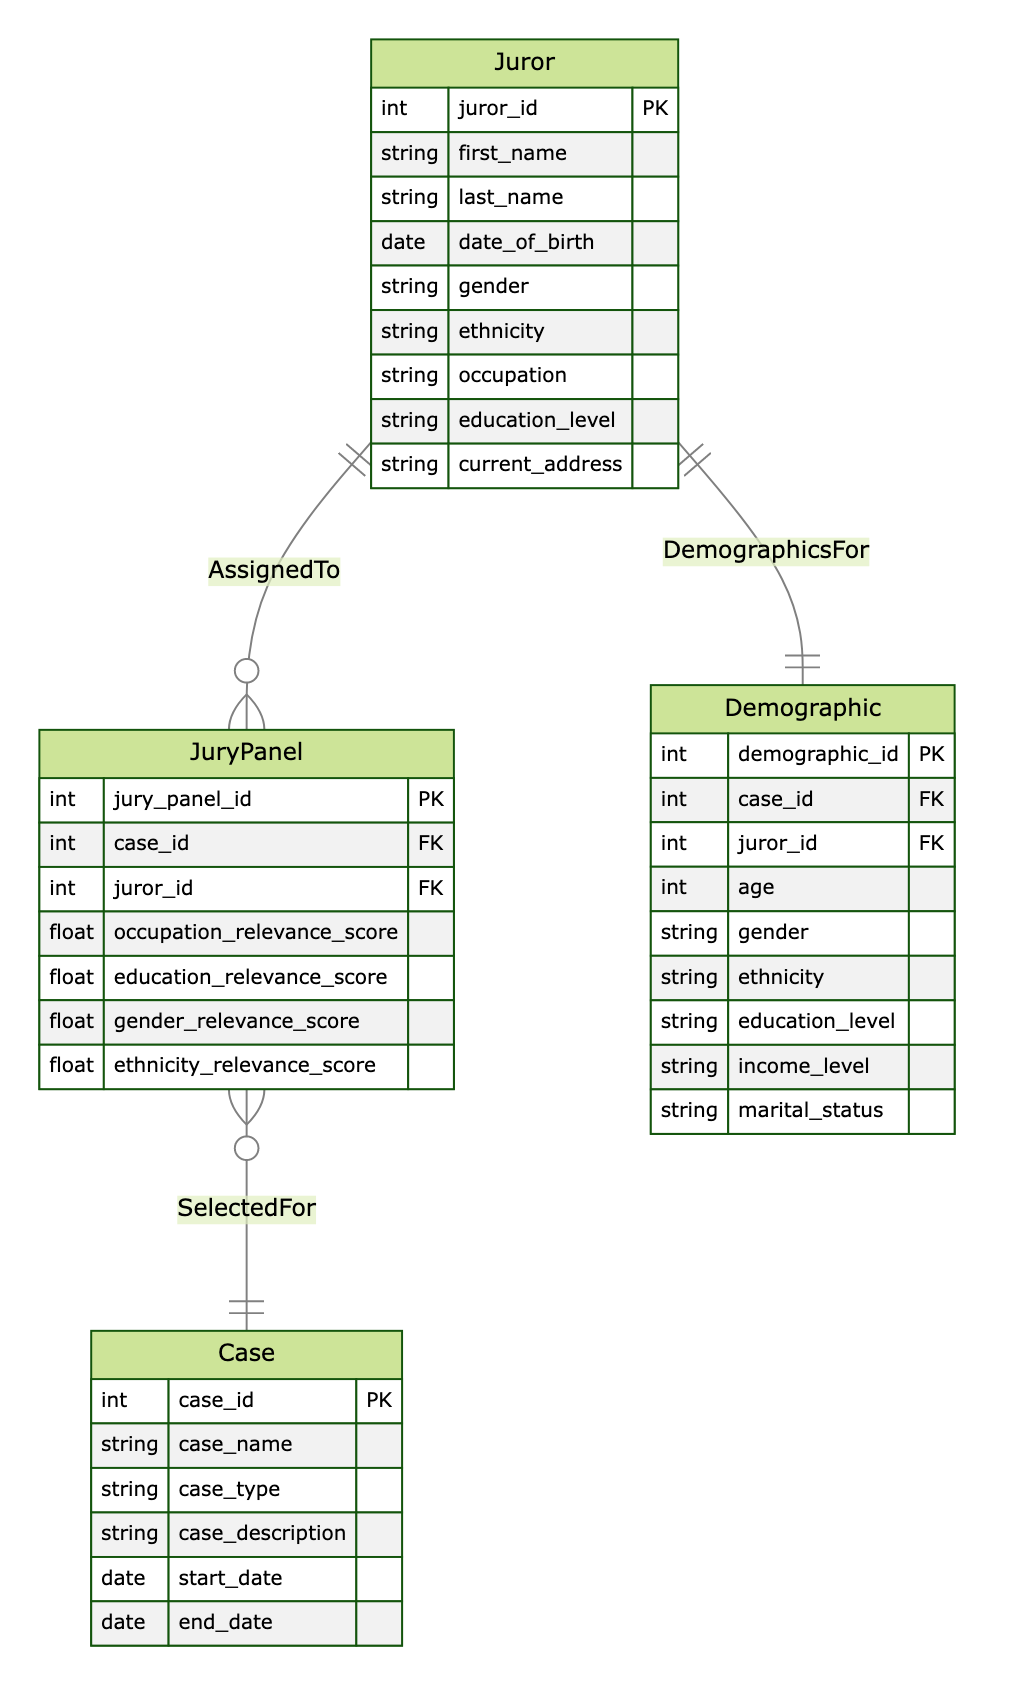What are the attributes of the Juror entity? The Juror entity has the following attributes: juror_id, first_name, last_name, date_of_birth, gender, ethnicity, occupation, education_level, and current_address.
Answer: juror_id, first_name, last_name, date_of_birth, gender, ethnicity, occupation, education_level, current_address How many entities are in the diagram? The diagram contains four entities: Juror, Case, JuryPanel, and Demographic.
Answer: 4 What is the relationship between JuryPanel and Case? The relationship between JuryPanel and Case is defined as "SelectedFor", indicating that a jury panel is selected for a specific case.
Answer: SelectedFor What attributes are associated with the JuryPanel entity? The JuryPanel entity has the attributes: jury_panel_id, case_id, juror_id, occupation_relevance_score, education_relevance_score, gender_relevance_score, and ethnicity_relevance_score.
Answer: jury_panel_id, case_id, juror_id, occupation_relevance_score, education_relevance_score, gender_relevance_score, ethnicity_relevance_score What does the AssignedTo relationship imply? The AssignedTo relationship implies that a juror is assigned to a jury panel, establishing a connection between the Juror and JuryPanel entities.
Answer: A juror is assigned to a jury panel How many attributes are in the Demographic entity? The Demographic entity has the attributes: demographic_id, case_id, juror_id, age, gender, ethnicity, education_level, income_level, and marital_status, totaling eight attributes.
Answer: 8 What can be concluded if a Juror has a high occupation relevance score? A high occupation relevance score indicates that the juror's occupation is particularly relevant to the case, potentially influencing their selection for the JuryPanel.
Answer: Influencing selection for the JuryPanel Which entity directly references the Case entity through foreign keys? The JuryPanel and Demographic entities both reference the Case entity through foreign keys: case_id.
Answer: JuryPanel and Demographic What is the primary key of the Case entity? The primary key of the Case entity is case_id, which uniquely identifies each case in the database.
Answer: case_id 